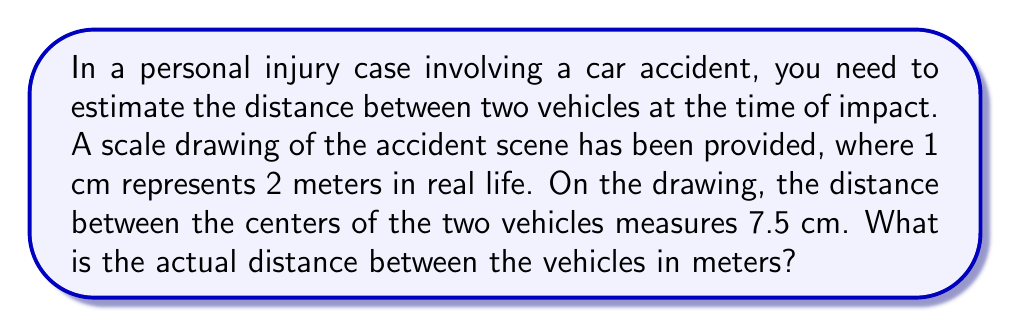Provide a solution to this math problem. To solve this problem, we need to use the given scale and convert the measured distance on the drawing to the actual distance in real life. Let's approach this step-by-step:

1. Given information:
   - Scale: 1 cm on the drawing = 2 meters in real life
   - Measured distance on the drawing: 7.5 cm

2. Set up the proportion:
   $\frac{1 \text{ cm}}{2 \text{ m}} = \frac{7.5 \text{ cm}}{x \text{ m}}$

3. Cross multiply:
   $1 \cdot x = 2 \cdot 7.5$

4. Solve for x:
   $x = 2 \cdot 7.5 = 15$

Therefore, the actual distance between the vehicles is 15 meters.
Answer: 15 meters 